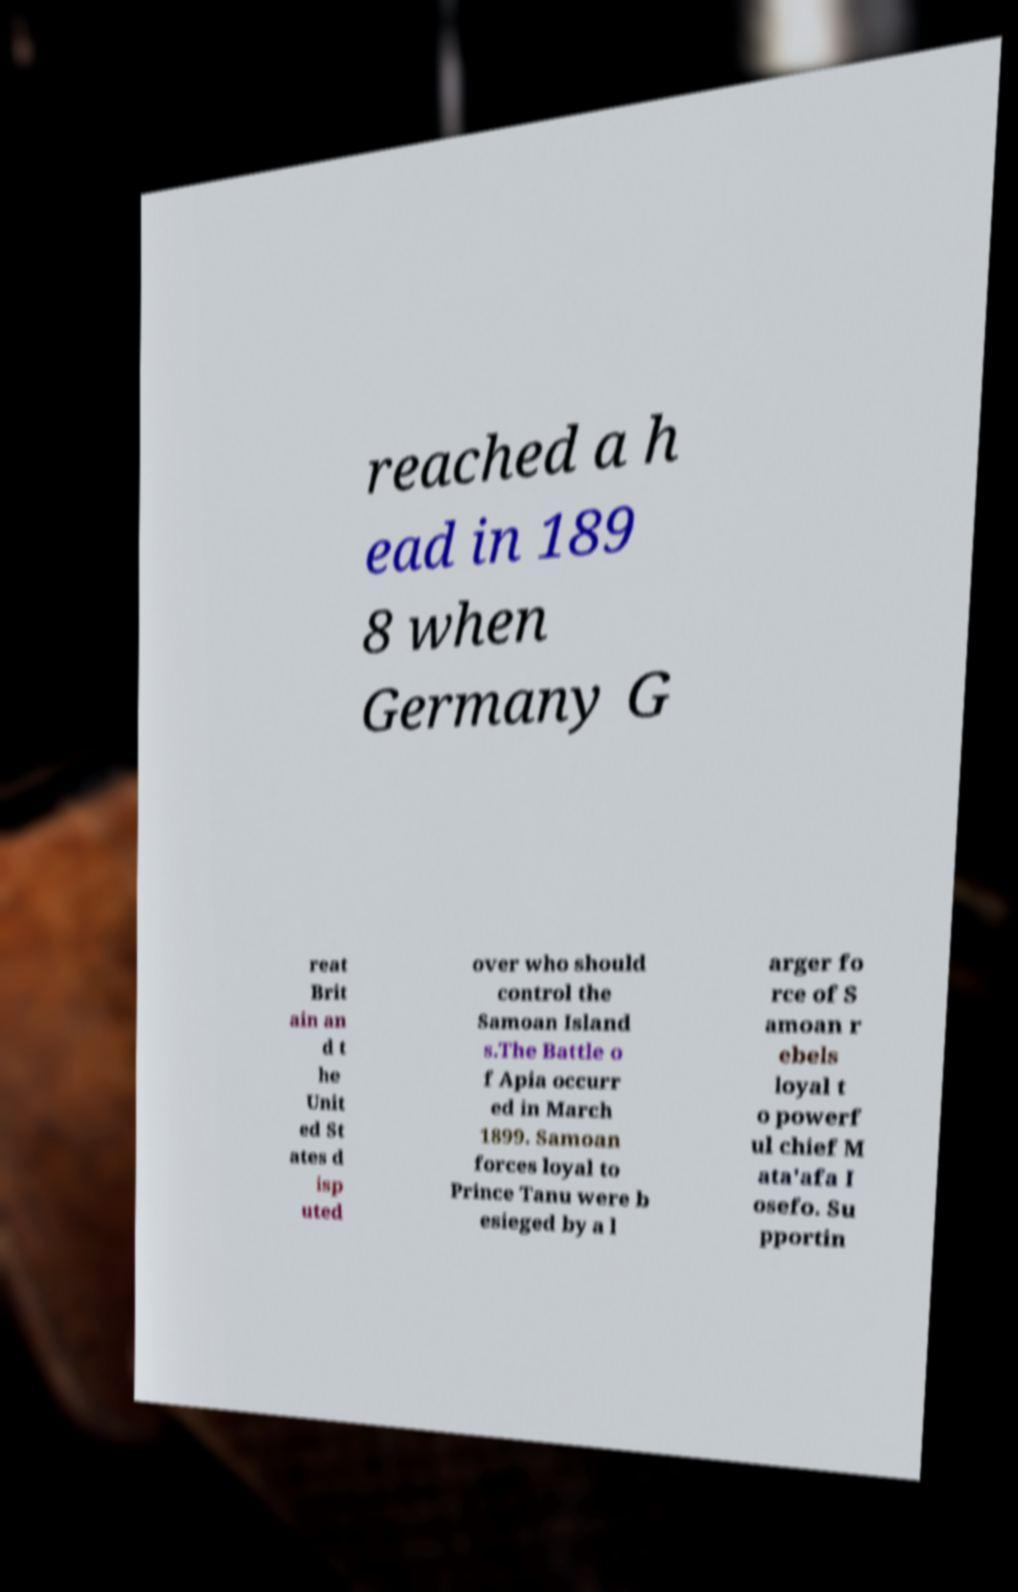There's text embedded in this image that I need extracted. Can you transcribe it verbatim? reached a h ead in 189 8 when Germany G reat Brit ain an d t he Unit ed St ates d isp uted over who should control the Samoan Island s.The Battle o f Apia occurr ed in March 1899. Samoan forces loyal to Prince Tanu were b esieged by a l arger fo rce of S amoan r ebels loyal t o powerf ul chief M ata'afa I osefo. Su pportin 